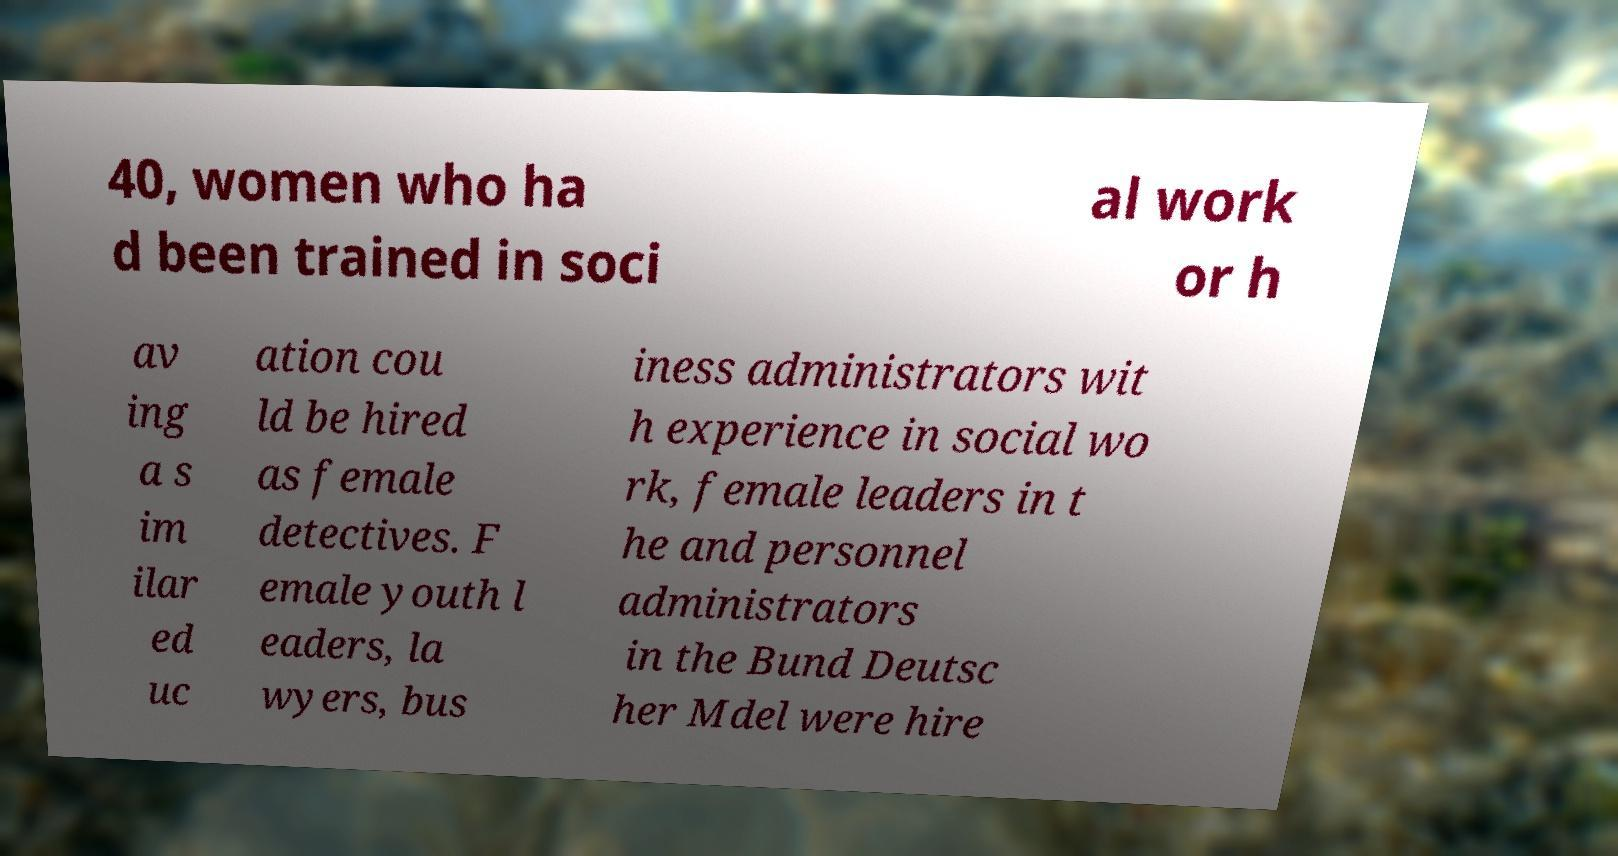Please read and relay the text visible in this image. What does it say? 40, women who ha d been trained in soci al work or h av ing a s im ilar ed uc ation cou ld be hired as female detectives. F emale youth l eaders, la wyers, bus iness administrators wit h experience in social wo rk, female leaders in t he and personnel administrators in the Bund Deutsc her Mdel were hire 